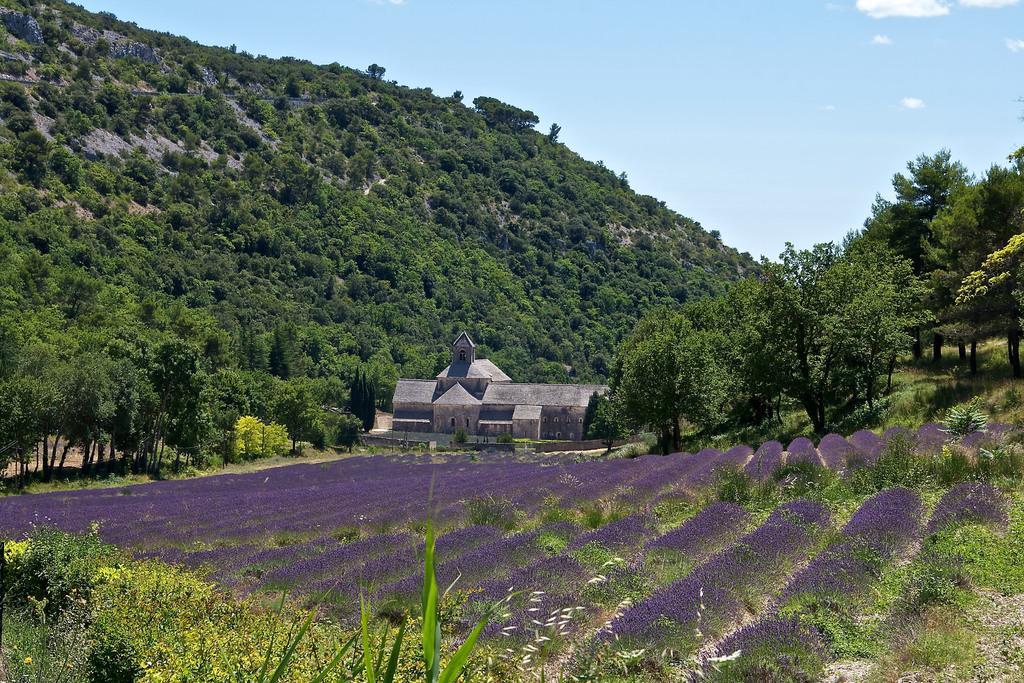Please provide a concise description of this image. In this picture there is a building and there are trees. At the top there is sky and there are clouds. At the bottom there are purple color flowers and there are plants. 